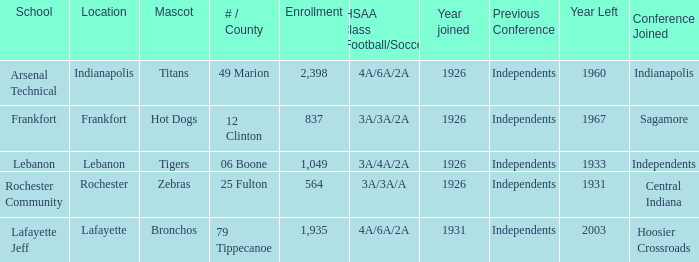What is the mean enrollment with hot dogs as the mascot, having a year joined post-1926? None. 